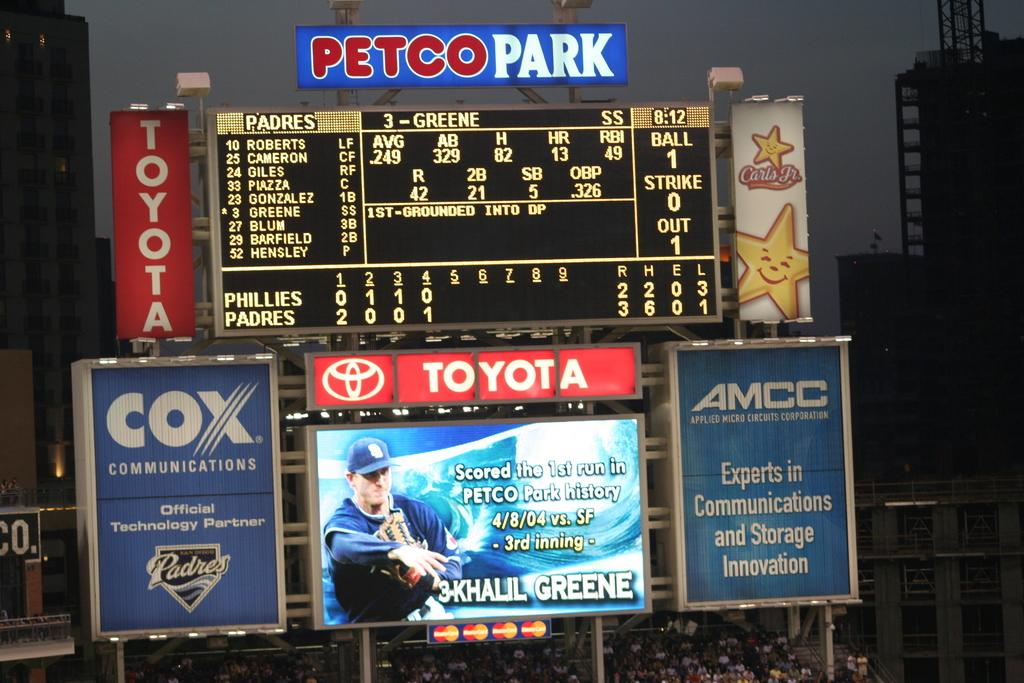<image>
Create a compact narrative representing the image presented. The Petco Park scoreboard gives the latest info on the Padres vs. Phillies game. 